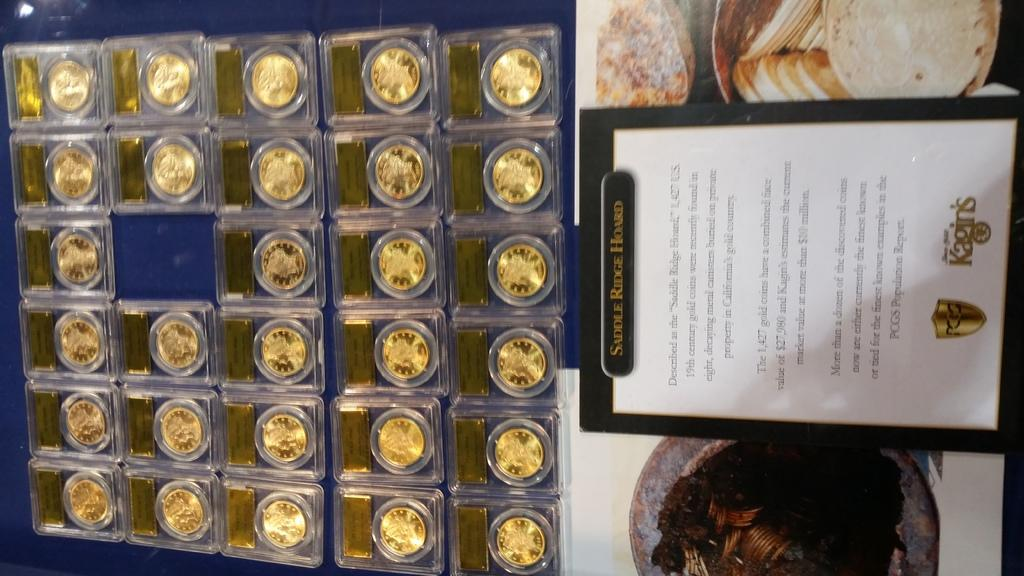<image>
Give a short and clear explanation of the subsequent image. A number of 19th century gold coins on display in individual cases. 